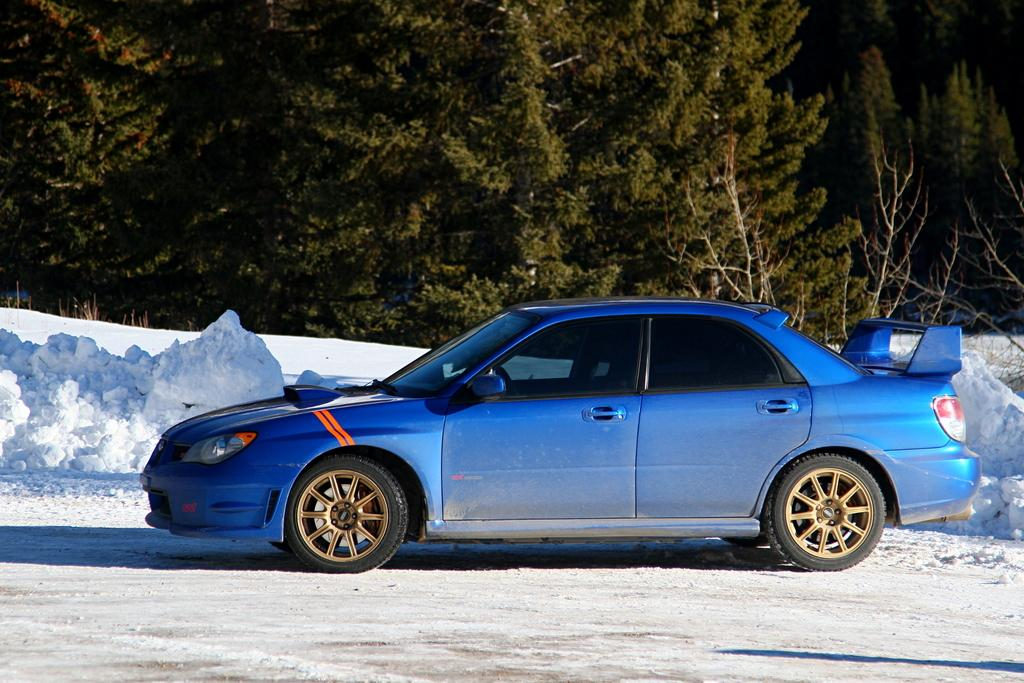What color is the car in the image? The car in the image is blue. What type of vegetation can be seen in the image? There are green color trees in the image. What type of zephyr can be seen blowing through the canvas in the image? There is no canvas or zephyr present in the image; it features a blue car and green trees. 